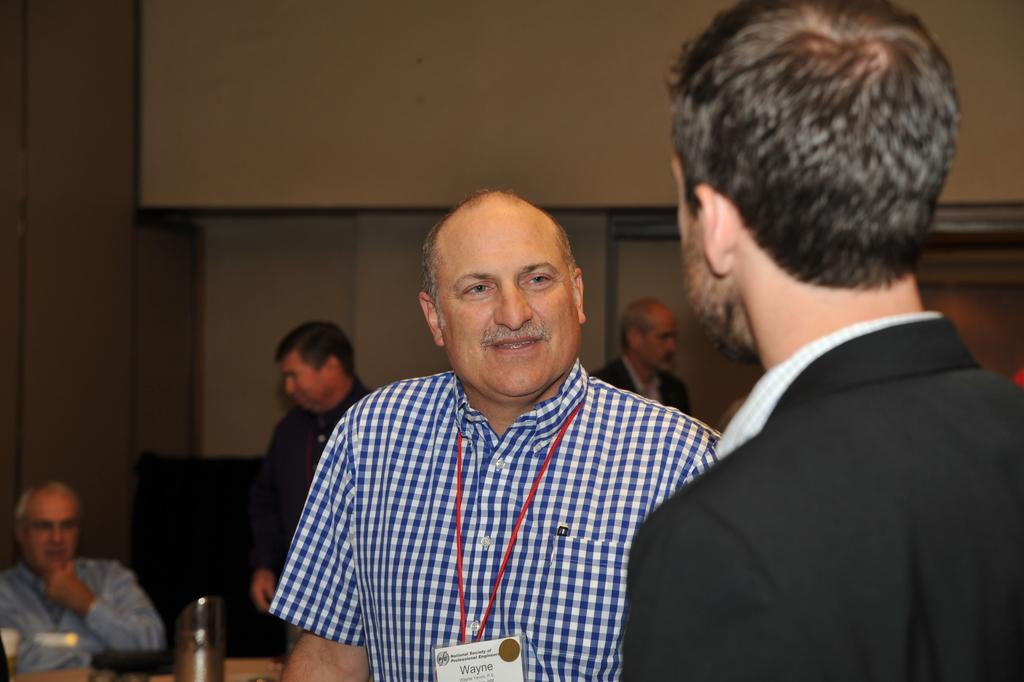How many people are present in the image? There are two people in the image. Can you describe one of the people in the image? One person is wearing an ID card. What can be seen in the background of the image? There are people, a wall, and some objects in the background of the image. What type of whistle can be heard in the image? There is no whistle present in the image, and therefore no sound can be heard. How many lines are visible in the image? The image does not contain any lines, so it is not possible to determine the number of lines. 